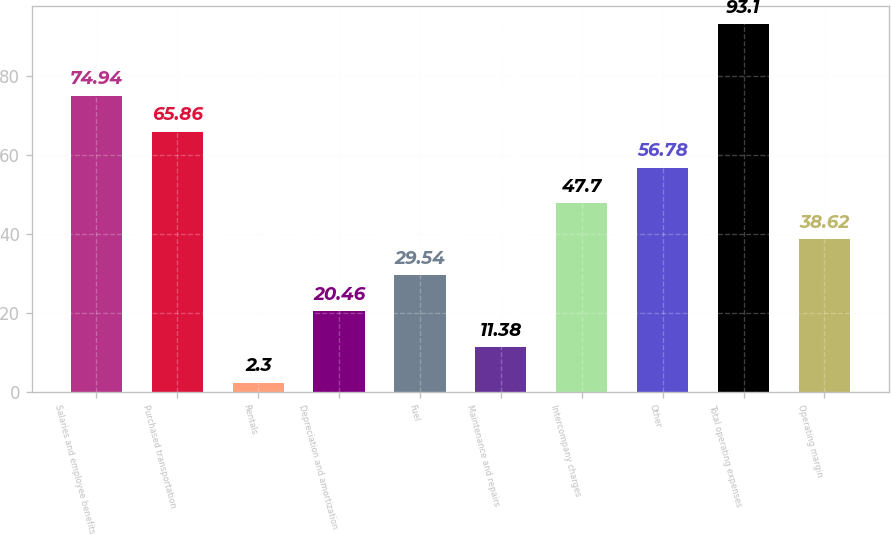Convert chart to OTSL. <chart><loc_0><loc_0><loc_500><loc_500><bar_chart><fcel>Salaries and employee benefits<fcel>Purchased transportation<fcel>Rentals<fcel>Depreciation and amortization<fcel>Fuel<fcel>Maintenance and repairs<fcel>Intercompany charges<fcel>Other<fcel>Total operating expenses<fcel>Operating margin<nl><fcel>74.94<fcel>65.86<fcel>2.3<fcel>20.46<fcel>29.54<fcel>11.38<fcel>47.7<fcel>56.78<fcel>93.1<fcel>38.62<nl></chart> 